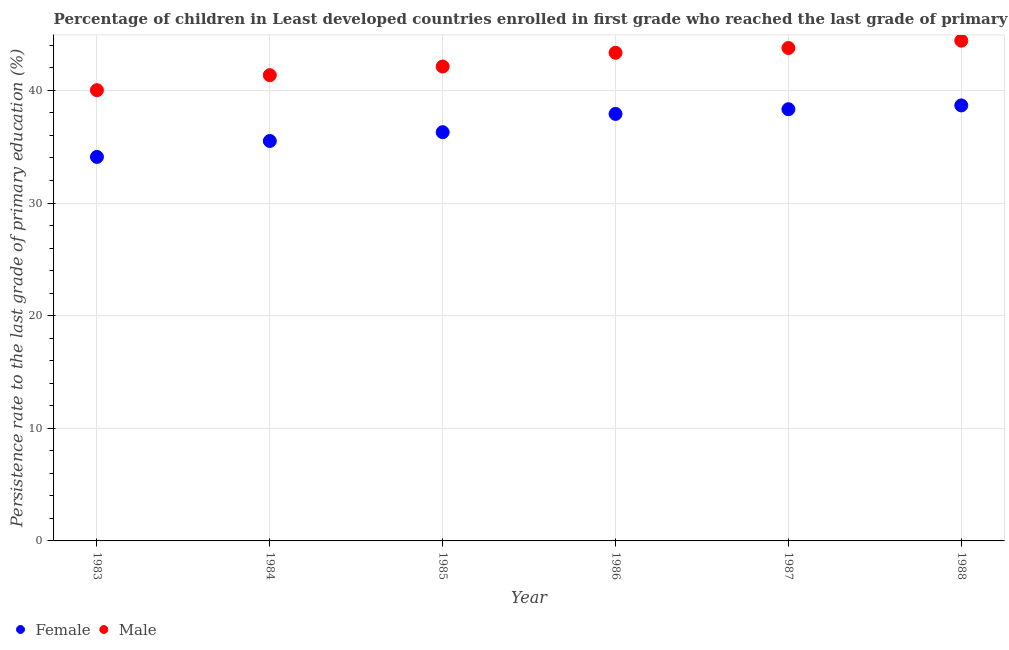What is the persistence rate of male students in 1987?
Your answer should be very brief. 43.77. Across all years, what is the maximum persistence rate of male students?
Provide a succinct answer. 44.42. Across all years, what is the minimum persistence rate of female students?
Your answer should be compact. 34.1. In which year was the persistence rate of female students maximum?
Make the answer very short. 1988. In which year was the persistence rate of male students minimum?
Your response must be concise. 1983. What is the total persistence rate of male students in the graph?
Give a very brief answer. 255.02. What is the difference between the persistence rate of female students in 1985 and that in 1987?
Your answer should be very brief. -2.04. What is the difference between the persistence rate of female students in 1987 and the persistence rate of male students in 1983?
Give a very brief answer. -1.69. What is the average persistence rate of female students per year?
Offer a very short reply. 36.8. In the year 1986, what is the difference between the persistence rate of female students and persistence rate of male students?
Ensure brevity in your answer.  -5.43. In how many years, is the persistence rate of male students greater than 2 %?
Your response must be concise. 6. What is the ratio of the persistence rate of female students in 1984 to that in 1987?
Your answer should be compact. 0.93. Is the persistence rate of female students in 1984 less than that in 1987?
Offer a very short reply. Yes. Is the difference between the persistence rate of female students in 1983 and 1985 greater than the difference between the persistence rate of male students in 1983 and 1985?
Offer a very short reply. No. What is the difference between the highest and the second highest persistence rate of female students?
Offer a very short reply. 0.34. What is the difference between the highest and the lowest persistence rate of male students?
Your answer should be very brief. 4.4. In how many years, is the persistence rate of female students greater than the average persistence rate of female students taken over all years?
Your answer should be very brief. 3. Is the sum of the persistence rate of male students in 1983 and 1984 greater than the maximum persistence rate of female students across all years?
Your answer should be compact. Yes. How many years are there in the graph?
Your answer should be compact. 6. Does the graph contain grids?
Make the answer very short. Yes. How are the legend labels stacked?
Provide a succinct answer. Horizontal. What is the title of the graph?
Offer a very short reply. Percentage of children in Least developed countries enrolled in first grade who reached the last grade of primary education. What is the label or title of the X-axis?
Your answer should be very brief. Year. What is the label or title of the Y-axis?
Provide a short and direct response. Persistence rate to the last grade of primary education (%). What is the Persistence rate to the last grade of primary education (%) in Female in 1983?
Ensure brevity in your answer.  34.1. What is the Persistence rate to the last grade of primary education (%) of Male in 1983?
Keep it short and to the point. 40.02. What is the Persistence rate to the last grade of primary education (%) in Female in 1984?
Provide a short and direct response. 35.51. What is the Persistence rate to the last grade of primary education (%) in Male in 1984?
Offer a terse response. 41.35. What is the Persistence rate to the last grade of primary education (%) in Female in 1985?
Offer a terse response. 36.29. What is the Persistence rate to the last grade of primary education (%) in Male in 1985?
Offer a terse response. 42.12. What is the Persistence rate to the last grade of primary education (%) in Female in 1986?
Offer a terse response. 37.91. What is the Persistence rate to the last grade of primary education (%) in Male in 1986?
Give a very brief answer. 43.34. What is the Persistence rate to the last grade of primary education (%) in Female in 1987?
Give a very brief answer. 38.33. What is the Persistence rate to the last grade of primary education (%) in Male in 1987?
Your response must be concise. 43.77. What is the Persistence rate to the last grade of primary education (%) in Female in 1988?
Provide a short and direct response. 38.67. What is the Persistence rate to the last grade of primary education (%) in Male in 1988?
Ensure brevity in your answer.  44.42. Across all years, what is the maximum Persistence rate to the last grade of primary education (%) in Female?
Make the answer very short. 38.67. Across all years, what is the maximum Persistence rate to the last grade of primary education (%) of Male?
Make the answer very short. 44.42. Across all years, what is the minimum Persistence rate to the last grade of primary education (%) in Female?
Your response must be concise. 34.1. Across all years, what is the minimum Persistence rate to the last grade of primary education (%) in Male?
Offer a very short reply. 40.02. What is the total Persistence rate to the last grade of primary education (%) in Female in the graph?
Ensure brevity in your answer.  220.81. What is the total Persistence rate to the last grade of primary education (%) in Male in the graph?
Your answer should be very brief. 255.02. What is the difference between the Persistence rate to the last grade of primary education (%) of Female in 1983 and that in 1984?
Make the answer very short. -1.41. What is the difference between the Persistence rate to the last grade of primary education (%) of Male in 1983 and that in 1984?
Give a very brief answer. -1.33. What is the difference between the Persistence rate to the last grade of primary education (%) of Female in 1983 and that in 1985?
Provide a short and direct response. -2.19. What is the difference between the Persistence rate to the last grade of primary education (%) of Male in 1983 and that in 1985?
Your response must be concise. -2.1. What is the difference between the Persistence rate to the last grade of primary education (%) in Female in 1983 and that in 1986?
Keep it short and to the point. -3.82. What is the difference between the Persistence rate to the last grade of primary education (%) in Male in 1983 and that in 1986?
Your response must be concise. -3.32. What is the difference between the Persistence rate to the last grade of primary education (%) of Female in 1983 and that in 1987?
Your response must be concise. -4.23. What is the difference between the Persistence rate to the last grade of primary education (%) in Male in 1983 and that in 1987?
Your answer should be compact. -3.75. What is the difference between the Persistence rate to the last grade of primary education (%) in Female in 1983 and that in 1988?
Offer a terse response. -4.57. What is the difference between the Persistence rate to the last grade of primary education (%) of Male in 1983 and that in 1988?
Your answer should be compact. -4.4. What is the difference between the Persistence rate to the last grade of primary education (%) in Female in 1984 and that in 1985?
Ensure brevity in your answer.  -0.78. What is the difference between the Persistence rate to the last grade of primary education (%) of Male in 1984 and that in 1985?
Make the answer very short. -0.77. What is the difference between the Persistence rate to the last grade of primary education (%) in Female in 1984 and that in 1986?
Ensure brevity in your answer.  -2.4. What is the difference between the Persistence rate to the last grade of primary education (%) in Male in 1984 and that in 1986?
Your answer should be compact. -1.99. What is the difference between the Persistence rate to the last grade of primary education (%) of Female in 1984 and that in 1987?
Your answer should be compact. -2.82. What is the difference between the Persistence rate to the last grade of primary education (%) of Male in 1984 and that in 1987?
Offer a very short reply. -2.41. What is the difference between the Persistence rate to the last grade of primary education (%) in Female in 1984 and that in 1988?
Provide a succinct answer. -3.16. What is the difference between the Persistence rate to the last grade of primary education (%) of Male in 1984 and that in 1988?
Give a very brief answer. -3.06. What is the difference between the Persistence rate to the last grade of primary education (%) in Female in 1985 and that in 1986?
Make the answer very short. -1.62. What is the difference between the Persistence rate to the last grade of primary education (%) of Male in 1985 and that in 1986?
Provide a short and direct response. -1.22. What is the difference between the Persistence rate to the last grade of primary education (%) of Female in 1985 and that in 1987?
Your answer should be very brief. -2.04. What is the difference between the Persistence rate to the last grade of primary education (%) of Male in 1985 and that in 1987?
Offer a terse response. -1.64. What is the difference between the Persistence rate to the last grade of primary education (%) in Female in 1985 and that in 1988?
Offer a very short reply. -2.38. What is the difference between the Persistence rate to the last grade of primary education (%) of Male in 1985 and that in 1988?
Provide a succinct answer. -2.29. What is the difference between the Persistence rate to the last grade of primary education (%) of Female in 1986 and that in 1987?
Ensure brevity in your answer.  -0.42. What is the difference between the Persistence rate to the last grade of primary education (%) in Male in 1986 and that in 1987?
Your response must be concise. -0.42. What is the difference between the Persistence rate to the last grade of primary education (%) in Female in 1986 and that in 1988?
Offer a terse response. -0.75. What is the difference between the Persistence rate to the last grade of primary education (%) of Male in 1986 and that in 1988?
Ensure brevity in your answer.  -1.07. What is the difference between the Persistence rate to the last grade of primary education (%) of Female in 1987 and that in 1988?
Make the answer very short. -0.34. What is the difference between the Persistence rate to the last grade of primary education (%) in Male in 1987 and that in 1988?
Provide a short and direct response. -0.65. What is the difference between the Persistence rate to the last grade of primary education (%) of Female in 1983 and the Persistence rate to the last grade of primary education (%) of Male in 1984?
Your response must be concise. -7.26. What is the difference between the Persistence rate to the last grade of primary education (%) in Female in 1983 and the Persistence rate to the last grade of primary education (%) in Male in 1985?
Ensure brevity in your answer.  -8.03. What is the difference between the Persistence rate to the last grade of primary education (%) of Female in 1983 and the Persistence rate to the last grade of primary education (%) of Male in 1986?
Your response must be concise. -9.24. What is the difference between the Persistence rate to the last grade of primary education (%) of Female in 1983 and the Persistence rate to the last grade of primary education (%) of Male in 1987?
Make the answer very short. -9.67. What is the difference between the Persistence rate to the last grade of primary education (%) of Female in 1983 and the Persistence rate to the last grade of primary education (%) of Male in 1988?
Ensure brevity in your answer.  -10.32. What is the difference between the Persistence rate to the last grade of primary education (%) in Female in 1984 and the Persistence rate to the last grade of primary education (%) in Male in 1985?
Your answer should be very brief. -6.61. What is the difference between the Persistence rate to the last grade of primary education (%) of Female in 1984 and the Persistence rate to the last grade of primary education (%) of Male in 1986?
Make the answer very short. -7.83. What is the difference between the Persistence rate to the last grade of primary education (%) in Female in 1984 and the Persistence rate to the last grade of primary education (%) in Male in 1987?
Make the answer very short. -8.26. What is the difference between the Persistence rate to the last grade of primary education (%) in Female in 1984 and the Persistence rate to the last grade of primary education (%) in Male in 1988?
Offer a very short reply. -8.9. What is the difference between the Persistence rate to the last grade of primary education (%) of Female in 1985 and the Persistence rate to the last grade of primary education (%) of Male in 1986?
Offer a very short reply. -7.05. What is the difference between the Persistence rate to the last grade of primary education (%) of Female in 1985 and the Persistence rate to the last grade of primary education (%) of Male in 1987?
Offer a terse response. -7.47. What is the difference between the Persistence rate to the last grade of primary education (%) in Female in 1985 and the Persistence rate to the last grade of primary education (%) in Male in 1988?
Your response must be concise. -8.12. What is the difference between the Persistence rate to the last grade of primary education (%) in Female in 1986 and the Persistence rate to the last grade of primary education (%) in Male in 1987?
Provide a succinct answer. -5.85. What is the difference between the Persistence rate to the last grade of primary education (%) of Female in 1986 and the Persistence rate to the last grade of primary education (%) of Male in 1988?
Your response must be concise. -6.5. What is the difference between the Persistence rate to the last grade of primary education (%) in Female in 1987 and the Persistence rate to the last grade of primary education (%) in Male in 1988?
Keep it short and to the point. -6.08. What is the average Persistence rate to the last grade of primary education (%) of Female per year?
Provide a succinct answer. 36.8. What is the average Persistence rate to the last grade of primary education (%) in Male per year?
Your answer should be compact. 42.5. In the year 1983, what is the difference between the Persistence rate to the last grade of primary education (%) in Female and Persistence rate to the last grade of primary education (%) in Male?
Offer a terse response. -5.92. In the year 1984, what is the difference between the Persistence rate to the last grade of primary education (%) in Female and Persistence rate to the last grade of primary education (%) in Male?
Offer a terse response. -5.84. In the year 1985, what is the difference between the Persistence rate to the last grade of primary education (%) in Female and Persistence rate to the last grade of primary education (%) in Male?
Give a very brief answer. -5.83. In the year 1986, what is the difference between the Persistence rate to the last grade of primary education (%) of Female and Persistence rate to the last grade of primary education (%) of Male?
Offer a very short reply. -5.43. In the year 1987, what is the difference between the Persistence rate to the last grade of primary education (%) of Female and Persistence rate to the last grade of primary education (%) of Male?
Your answer should be very brief. -5.43. In the year 1988, what is the difference between the Persistence rate to the last grade of primary education (%) of Female and Persistence rate to the last grade of primary education (%) of Male?
Keep it short and to the point. -5.75. What is the ratio of the Persistence rate to the last grade of primary education (%) of Female in 1983 to that in 1984?
Ensure brevity in your answer.  0.96. What is the ratio of the Persistence rate to the last grade of primary education (%) in Female in 1983 to that in 1985?
Make the answer very short. 0.94. What is the ratio of the Persistence rate to the last grade of primary education (%) of Male in 1983 to that in 1985?
Your answer should be compact. 0.95. What is the ratio of the Persistence rate to the last grade of primary education (%) of Female in 1983 to that in 1986?
Offer a very short reply. 0.9. What is the ratio of the Persistence rate to the last grade of primary education (%) of Male in 1983 to that in 1986?
Make the answer very short. 0.92. What is the ratio of the Persistence rate to the last grade of primary education (%) of Female in 1983 to that in 1987?
Keep it short and to the point. 0.89. What is the ratio of the Persistence rate to the last grade of primary education (%) of Male in 1983 to that in 1987?
Offer a very short reply. 0.91. What is the ratio of the Persistence rate to the last grade of primary education (%) in Female in 1983 to that in 1988?
Keep it short and to the point. 0.88. What is the ratio of the Persistence rate to the last grade of primary education (%) of Male in 1983 to that in 1988?
Ensure brevity in your answer.  0.9. What is the ratio of the Persistence rate to the last grade of primary education (%) of Female in 1984 to that in 1985?
Keep it short and to the point. 0.98. What is the ratio of the Persistence rate to the last grade of primary education (%) in Male in 1984 to that in 1985?
Offer a terse response. 0.98. What is the ratio of the Persistence rate to the last grade of primary education (%) of Female in 1984 to that in 1986?
Provide a succinct answer. 0.94. What is the ratio of the Persistence rate to the last grade of primary education (%) in Male in 1984 to that in 1986?
Make the answer very short. 0.95. What is the ratio of the Persistence rate to the last grade of primary education (%) in Female in 1984 to that in 1987?
Ensure brevity in your answer.  0.93. What is the ratio of the Persistence rate to the last grade of primary education (%) of Male in 1984 to that in 1987?
Offer a very short reply. 0.94. What is the ratio of the Persistence rate to the last grade of primary education (%) of Female in 1984 to that in 1988?
Ensure brevity in your answer.  0.92. What is the ratio of the Persistence rate to the last grade of primary education (%) of Male in 1984 to that in 1988?
Your answer should be very brief. 0.93. What is the ratio of the Persistence rate to the last grade of primary education (%) in Female in 1985 to that in 1986?
Your answer should be very brief. 0.96. What is the ratio of the Persistence rate to the last grade of primary education (%) of Male in 1985 to that in 1986?
Your answer should be very brief. 0.97. What is the ratio of the Persistence rate to the last grade of primary education (%) in Female in 1985 to that in 1987?
Give a very brief answer. 0.95. What is the ratio of the Persistence rate to the last grade of primary education (%) of Male in 1985 to that in 1987?
Provide a short and direct response. 0.96. What is the ratio of the Persistence rate to the last grade of primary education (%) in Female in 1985 to that in 1988?
Provide a succinct answer. 0.94. What is the ratio of the Persistence rate to the last grade of primary education (%) of Male in 1985 to that in 1988?
Keep it short and to the point. 0.95. What is the ratio of the Persistence rate to the last grade of primary education (%) in Female in 1986 to that in 1987?
Your answer should be very brief. 0.99. What is the ratio of the Persistence rate to the last grade of primary education (%) in Male in 1986 to that in 1987?
Offer a terse response. 0.99. What is the ratio of the Persistence rate to the last grade of primary education (%) in Female in 1986 to that in 1988?
Provide a succinct answer. 0.98. What is the ratio of the Persistence rate to the last grade of primary education (%) of Male in 1986 to that in 1988?
Offer a terse response. 0.98. What is the ratio of the Persistence rate to the last grade of primary education (%) of Female in 1987 to that in 1988?
Ensure brevity in your answer.  0.99. What is the ratio of the Persistence rate to the last grade of primary education (%) in Male in 1987 to that in 1988?
Your response must be concise. 0.99. What is the difference between the highest and the second highest Persistence rate to the last grade of primary education (%) in Female?
Provide a succinct answer. 0.34. What is the difference between the highest and the second highest Persistence rate to the last grade of primary education (%) of Male?
Your answer should be very brief. 0.65. What is the difference between the highest and the lowest Persistence rate to the last grade of primary education (%) of Female?
Give a very brief answer. 4.57. What is the difference between the highest and the lowest Persistence rate to the last grade of primary education (%) of Male?
Keep it short and to the point. 4.4. 